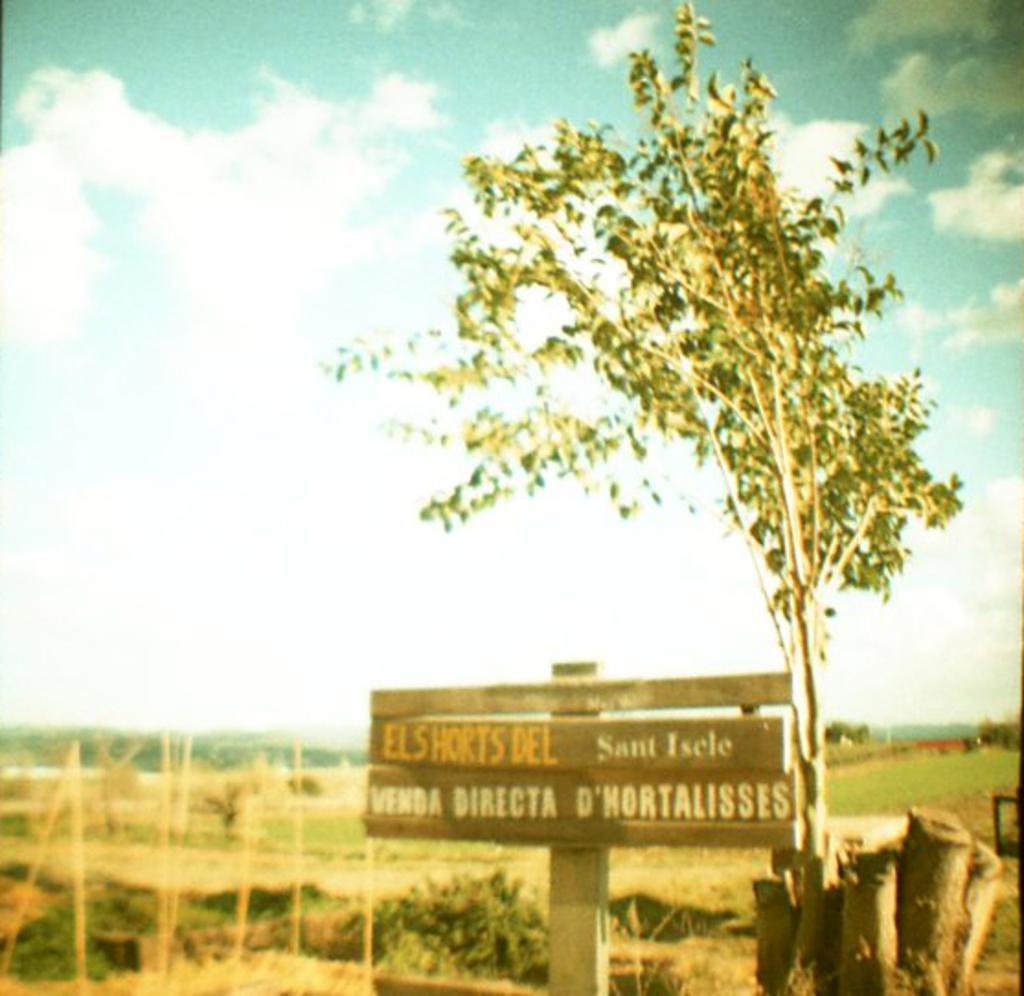Describe this image in one or two sentences. In this image I can see a pole to which I can see a board, a tree and few other wooden poles. In the background I can see the ground, some grass, few trees and the sky. 